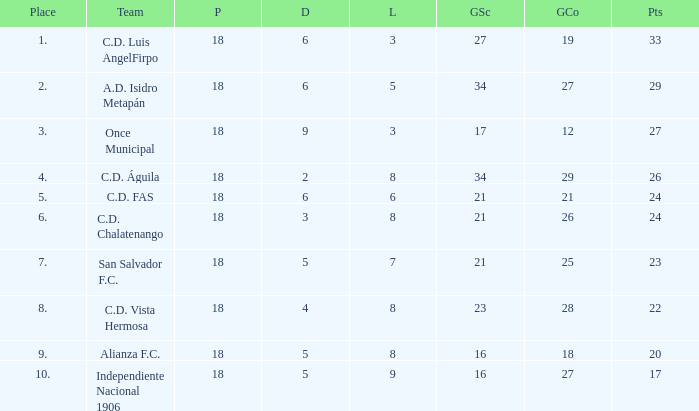What's the place that Once Municipal has a lost greater than 3? None. 